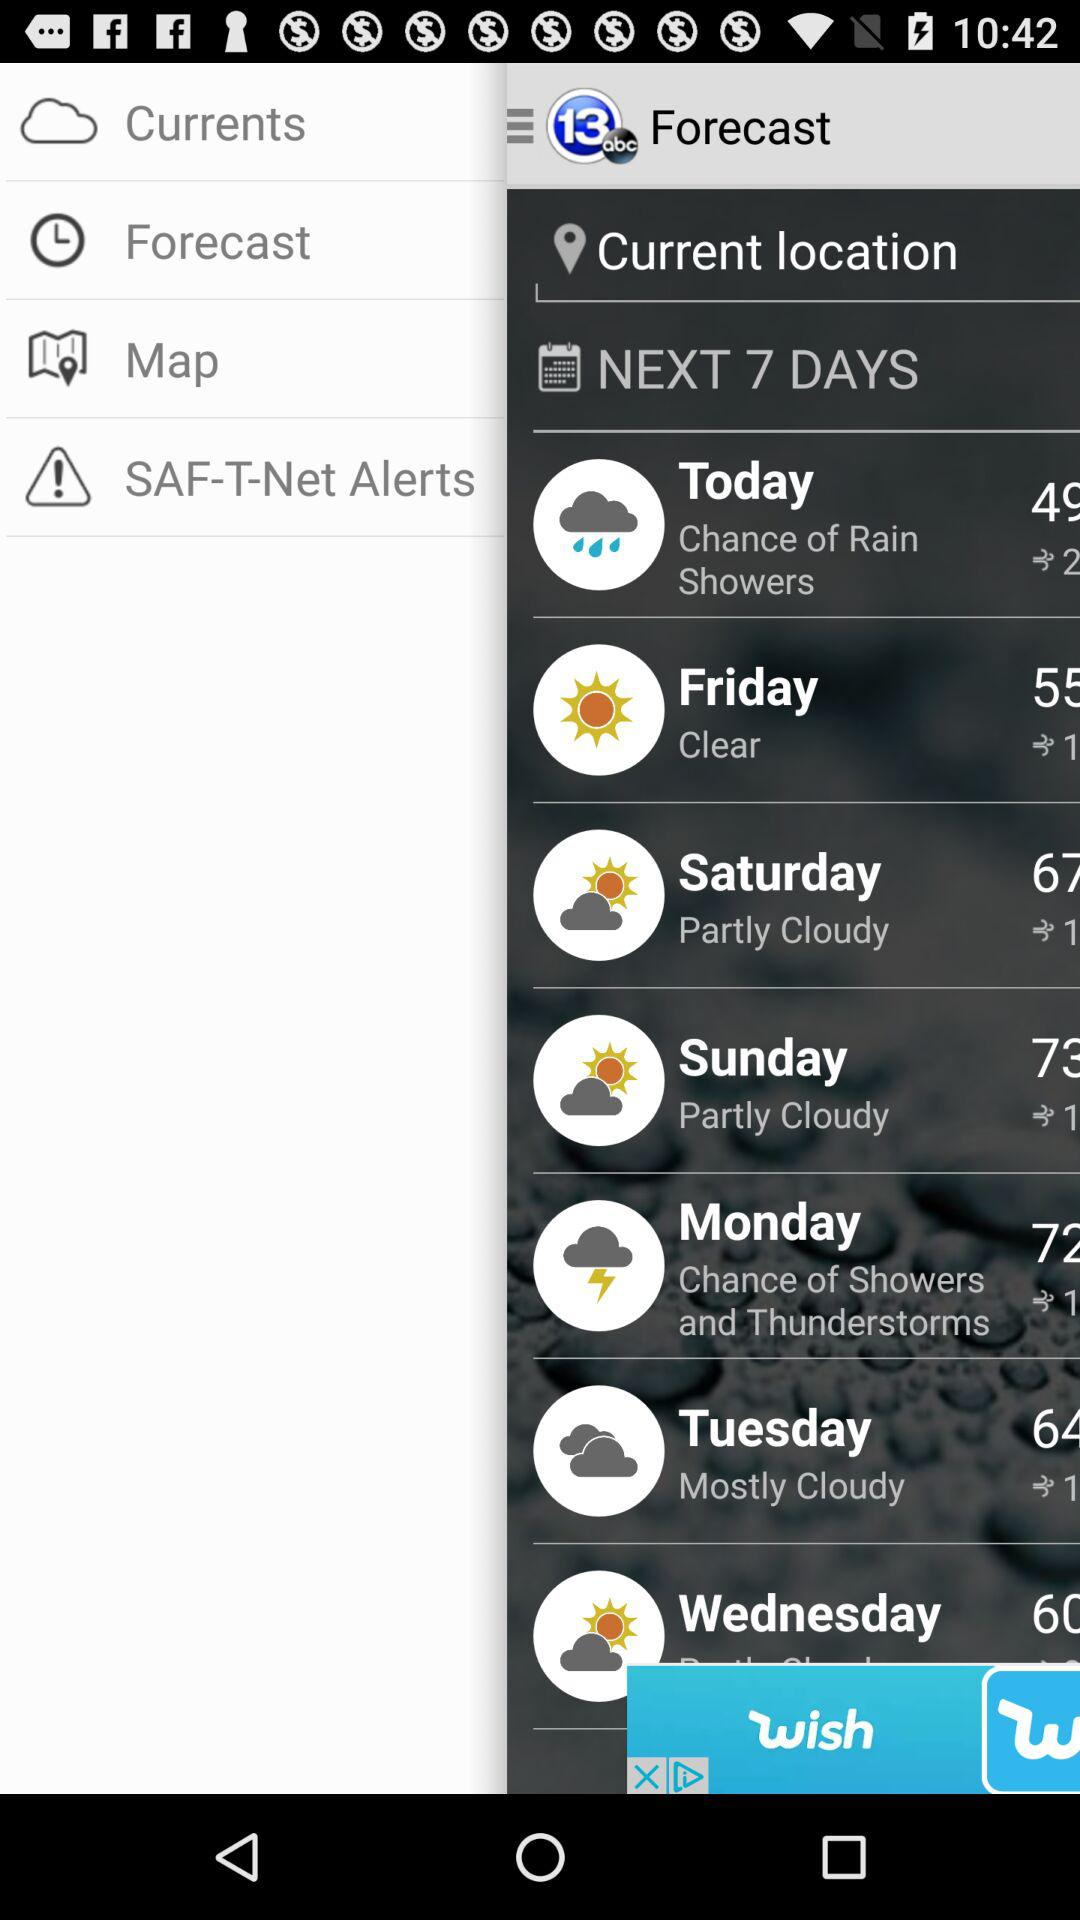What is the weather forecast for Monday? The weather forecast for Monday has a chance of showers and thunderstorms. 